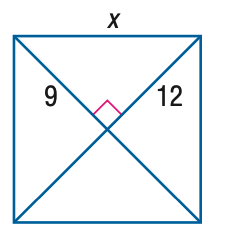Question: Find x.
Choices:
A. 13
B. 14
C. 15
D. 16
Answer with the letter. Answer: C 